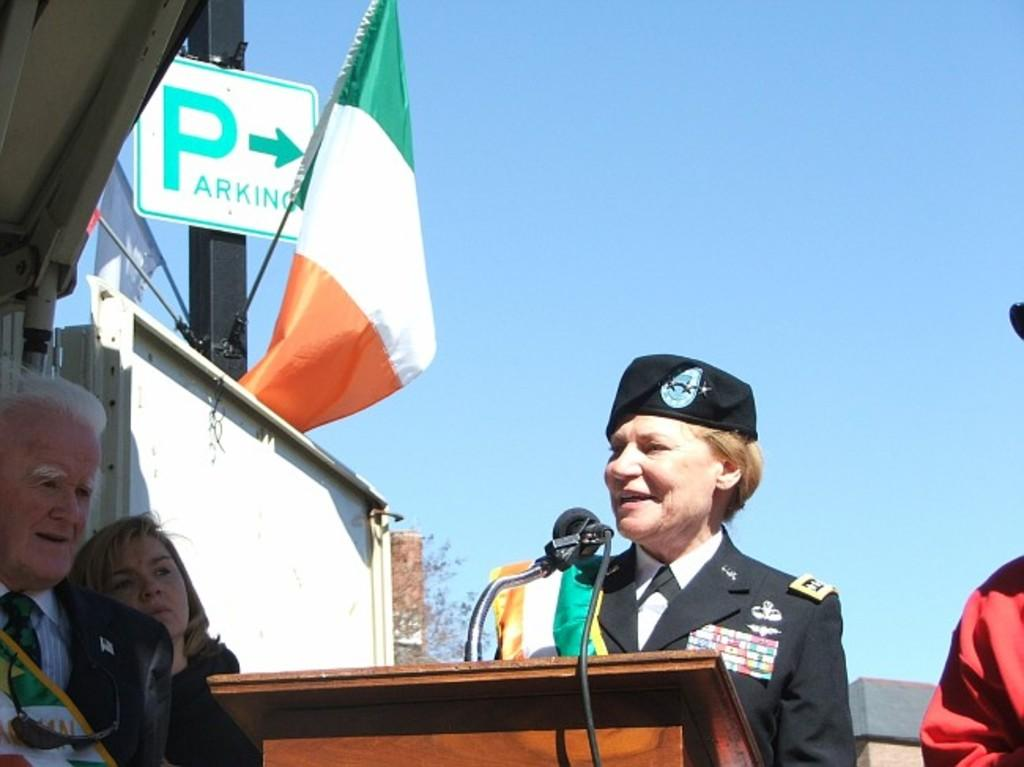How many people are in the image? There are people in the image, but the exact number is not specified. What is the main object on the stage in the image? There is a podium in the image. What is used for amplifying sound in the image? There is a microphone in the image. What can be seen in the background of the image? In the background of the image, there is a pole, flags, a board, trees, and the sky. What type of wound can be seen on the person's arm in the image? There is no wound visible on any person's arm in the image. Is there a lake visible in the background of the image? No, there is no lake present in the image; only trees and the sky are visible in the background. 